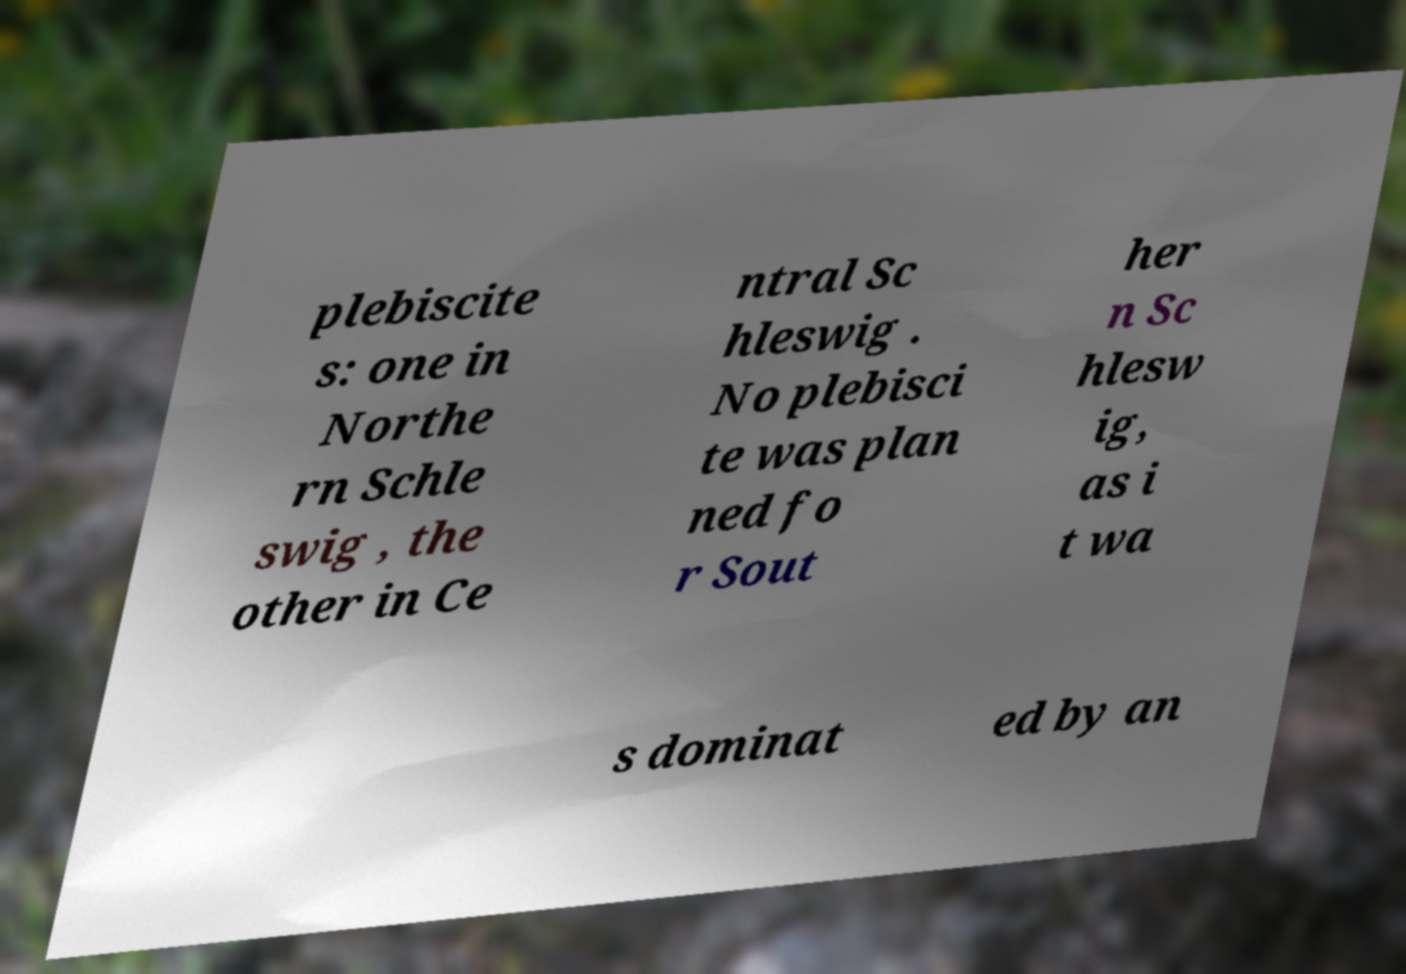Can you read and provide the text displayed in the image?This photo seems to have some interesting text. Can you extract and type it out for me? plebiscite s: one in Northe rn Schle swig , the other in Ce ntral Sc hleswig . No plebisci te was plan ned fo r Sout her n Sc hlesw ig, as i t wa s dominat ed by an 